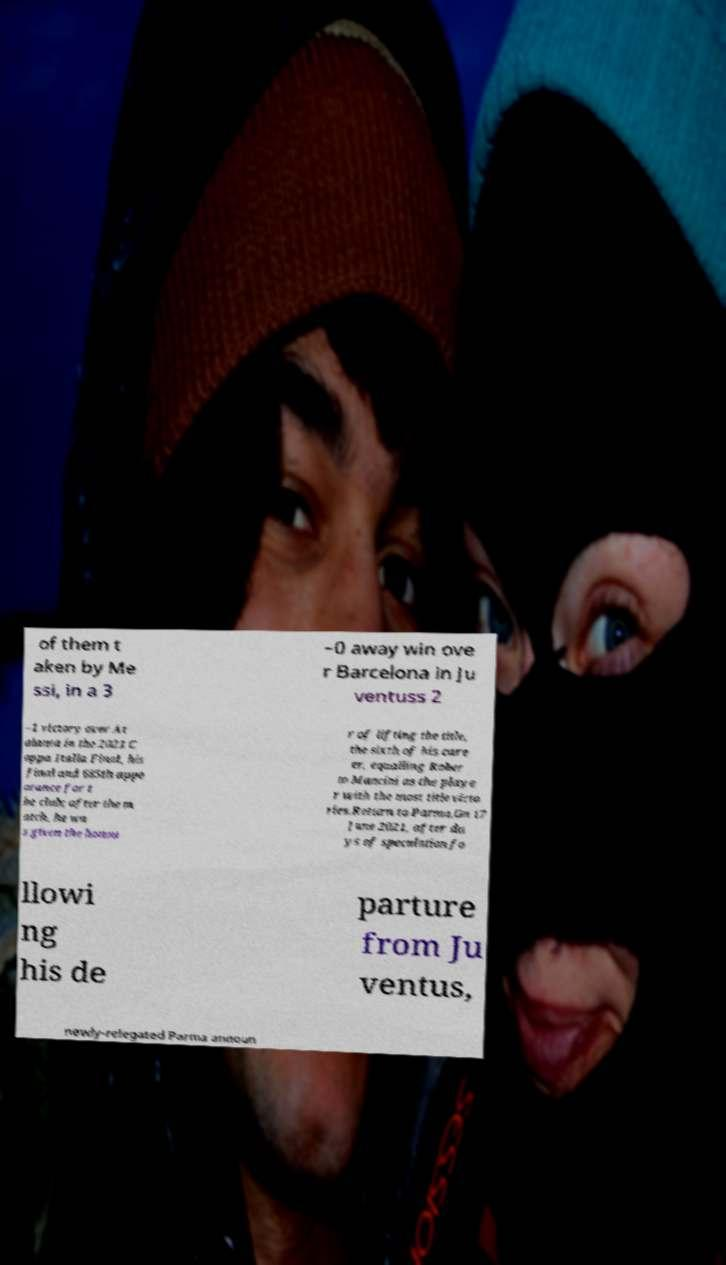Can you read and provide the text displayed in the image?This photo seems to have some interesting text. Can you extract and type it out for me? of them t aken by Me ssi, in a 3 –0 away win ove r Barcelona in Ju ventuss 2 –1 victory over At alanta in the 2021 C oppa Italia Final, his final and 685th appe arance for t he club; after the m atch, he wa s given the honou r of lifting the title, the sixth of his care er, equalling Rober to Mancini as the playe r with the most title victo ries.Return to Parma.On 17 June 2021, after da ys of speculation fo llowi ng his de parture from Ju ventus, newly-relegated Parma announ 